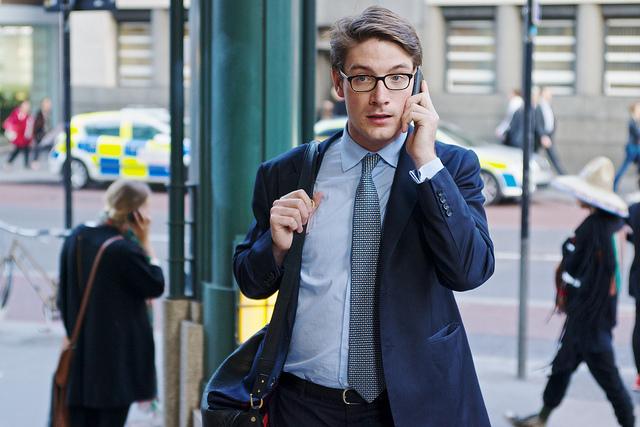Is this man wearing sunglasses?
Keep it brief. No. How many ladies in picture?
Quick response, please. 1. What color is this man's belt?
Keep it brief. Black. What is the man doing?
Give a very brief answer. Talking on phone. How many are smoking?
Keep it brief. 0. What color is his tie?
Concise answer only. Blue. 